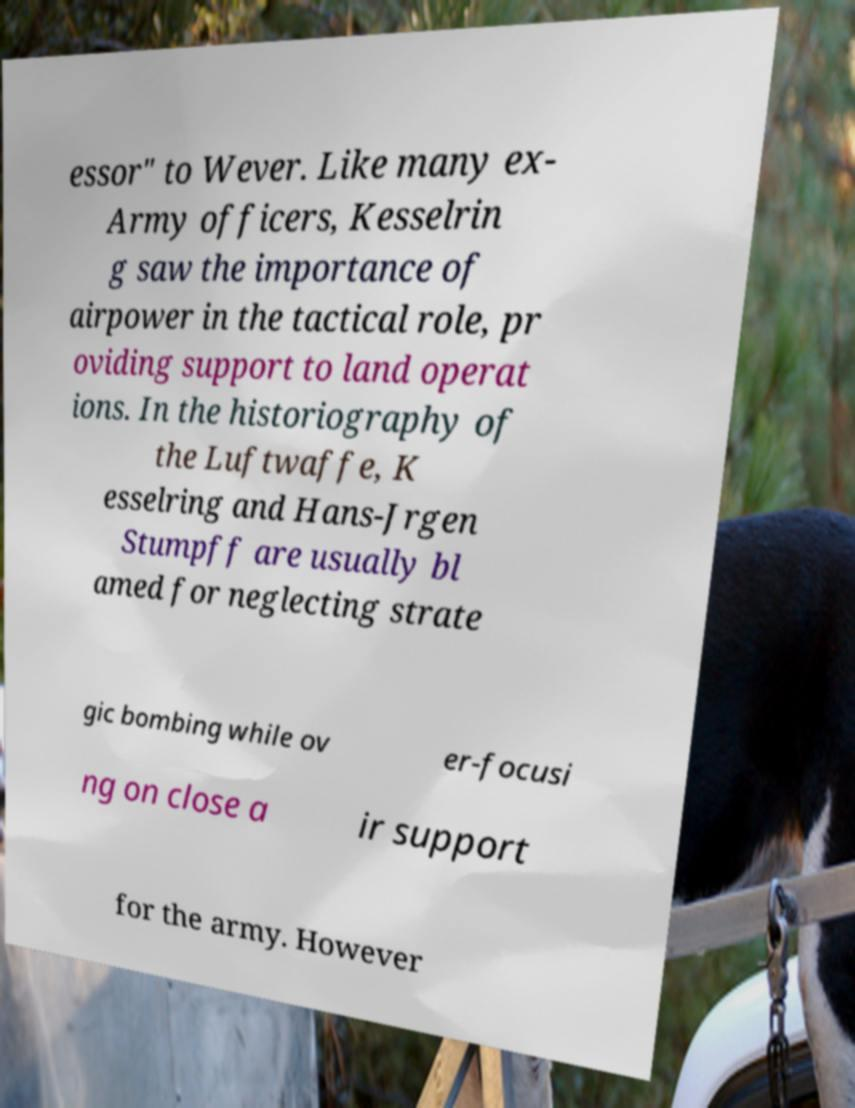What messages or text are displayed in this image? I need them in a readable, typed format. essor" to Wever. Like many ex- Army officers, Kesselrin g saw the importance of airpower in the tactical role, pr oviding support to land operat ions. In the historiography of the Luftwaffe, K esselring and Hans-Jrgen Stumpff are usually bl amed for neglecting strate gic bombing while ov er-focusi ng on close a ir support for the army. However 